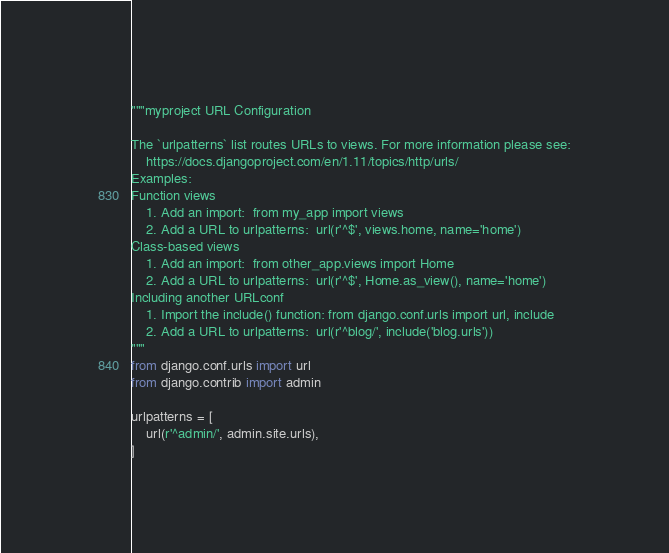Convert code to text. <code><loc_0><loc_0><loc_500><loc_500><_Python_>"""myproject URL Configuration

The `urlpatterns` list routes URLs to views. For more information please see:
    https://docs.djangoproject.com/en/1.11/topics/http/urls/
Examples:
Function views
    1. Add an import:  from my_app import views
    2. Add a URL to urlpatterns:  url(r'^$', views.home, name='home')
Class-based views
    1. Add an import:  from other_app.views import Home
    2. Add a URL to urlpatterns:  url(r'^$', Home.as_view(), name='home')
Including another URLconf
    1. Import the include() function: from django.conf.urls import url, include
    2. Add a URL to urlpatterns:  url(r'^blog/', include('blog.urls'))
"""
from django.conf.urls import url
from django.contrib import admin

urlpatterns = [
    url(r'^admin/', admin.site.urls),
]
</code> 